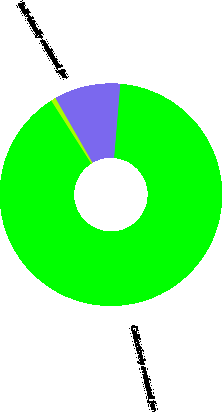Convert chart to OTSL. <chart><loc_0><loc_0><loc_500><loc_500><pie_chart><fcel>Individually evaluated for<fcel>Collectively evaluated for<fcel>Purchased impaired<nl><fcel>0.73%<fcel>89.64%<fcel>9.62%<nl></chart> 